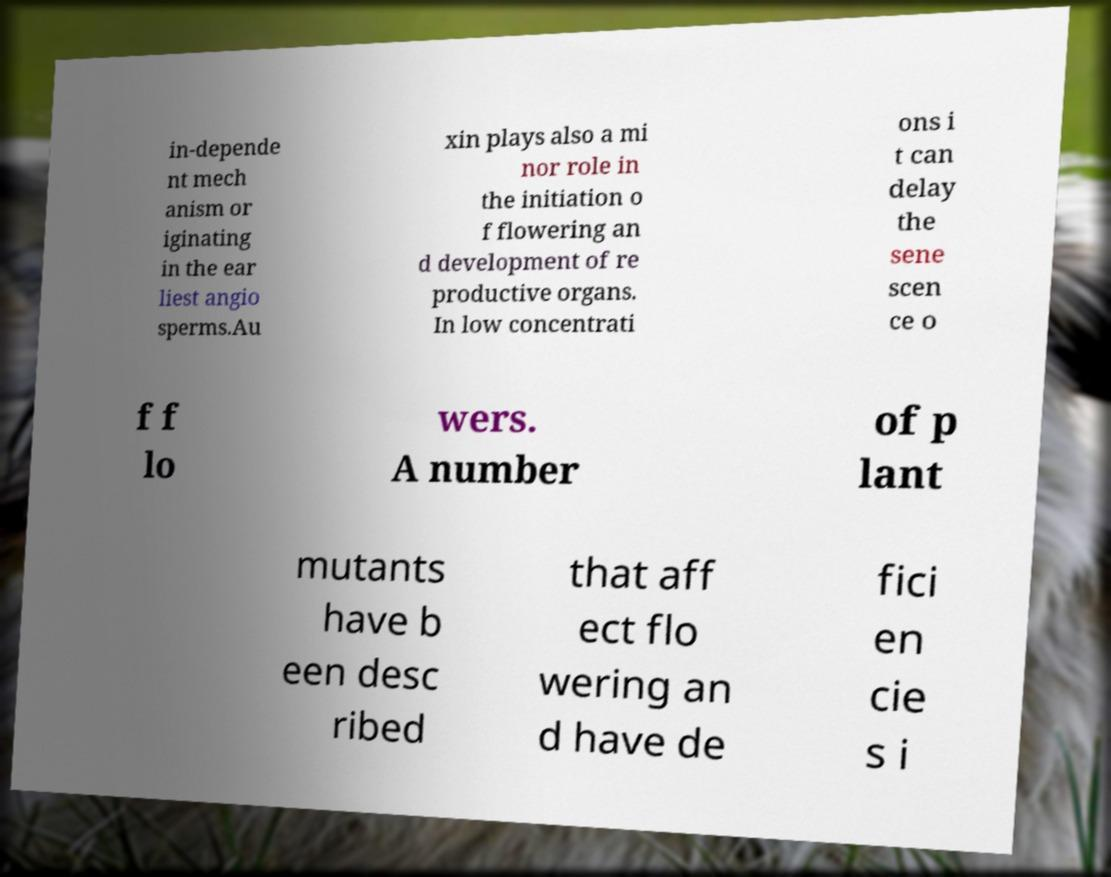There's text embedded in this image that I need extracted. Can you transcribe it verbatim? in-depende nt mech anism or iginating in the ear liest angio sperms.Au xin plays also a mi nor role in the initiation o f flowering an d development of re productive organs. In low concentrati ons i t can delay the sene scen ce o f f lo wers. A number of p lant mutants have b een desc ribed that aff ect flo wering an d have de fici en cie s i 